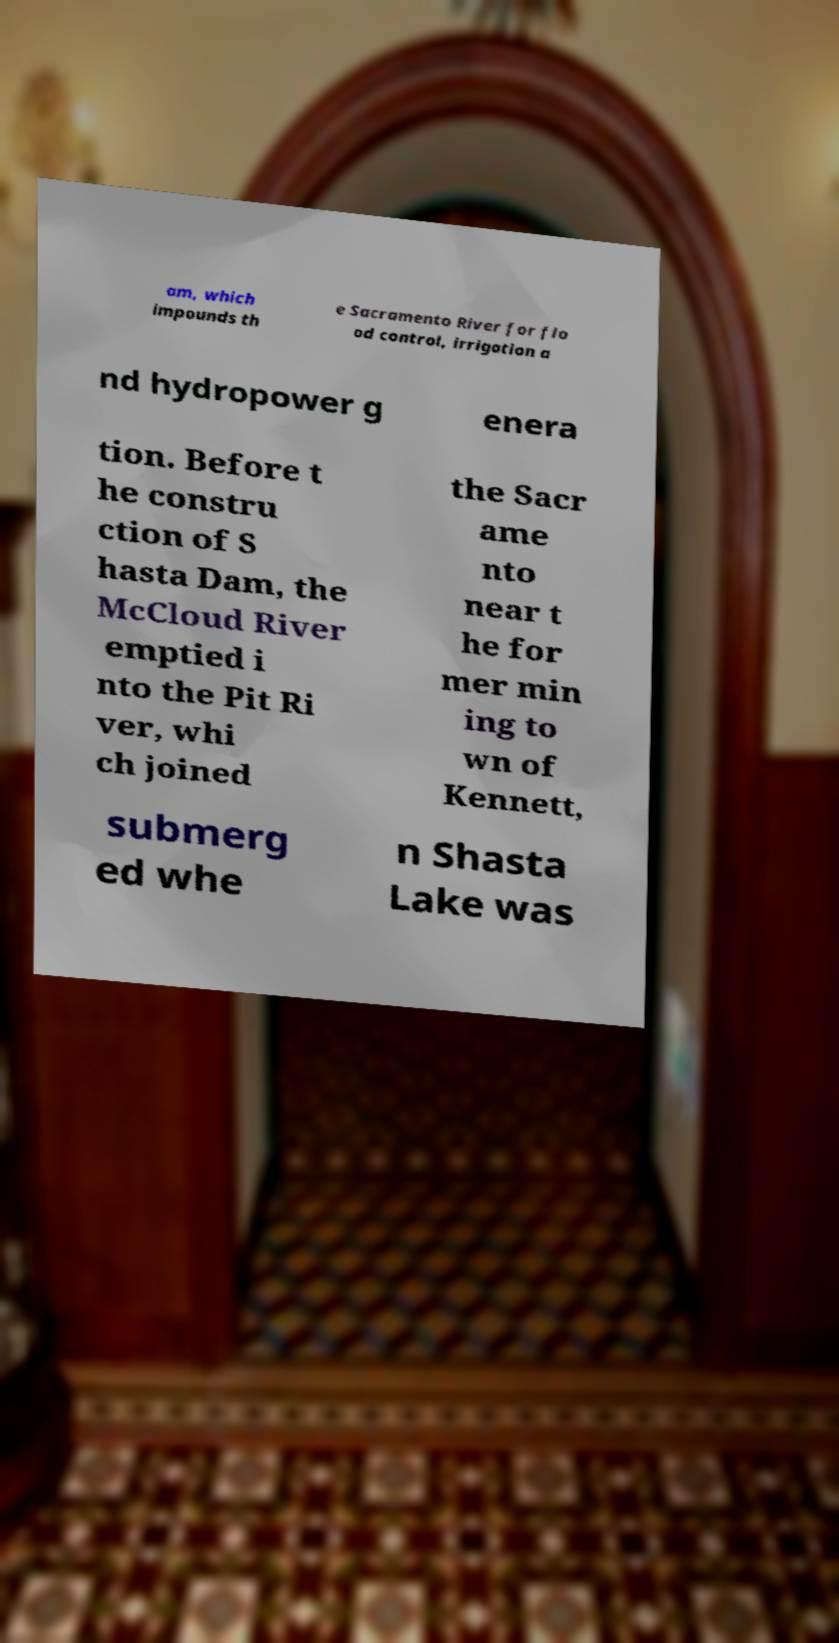I need the written content from this picture converted into text. Can you do that? am, which impounds th e Sacramento River for flo od control, irrigation a nd hydropower g enera tion. Before t he constru ction of S hasta Dam, the McCloud River emptied i nto the Pit Ri ver, whi ch joined the Sacr ame nto near t he for mer min ing to wn of Kennett, submerg ed whe n Shasta Lake was 